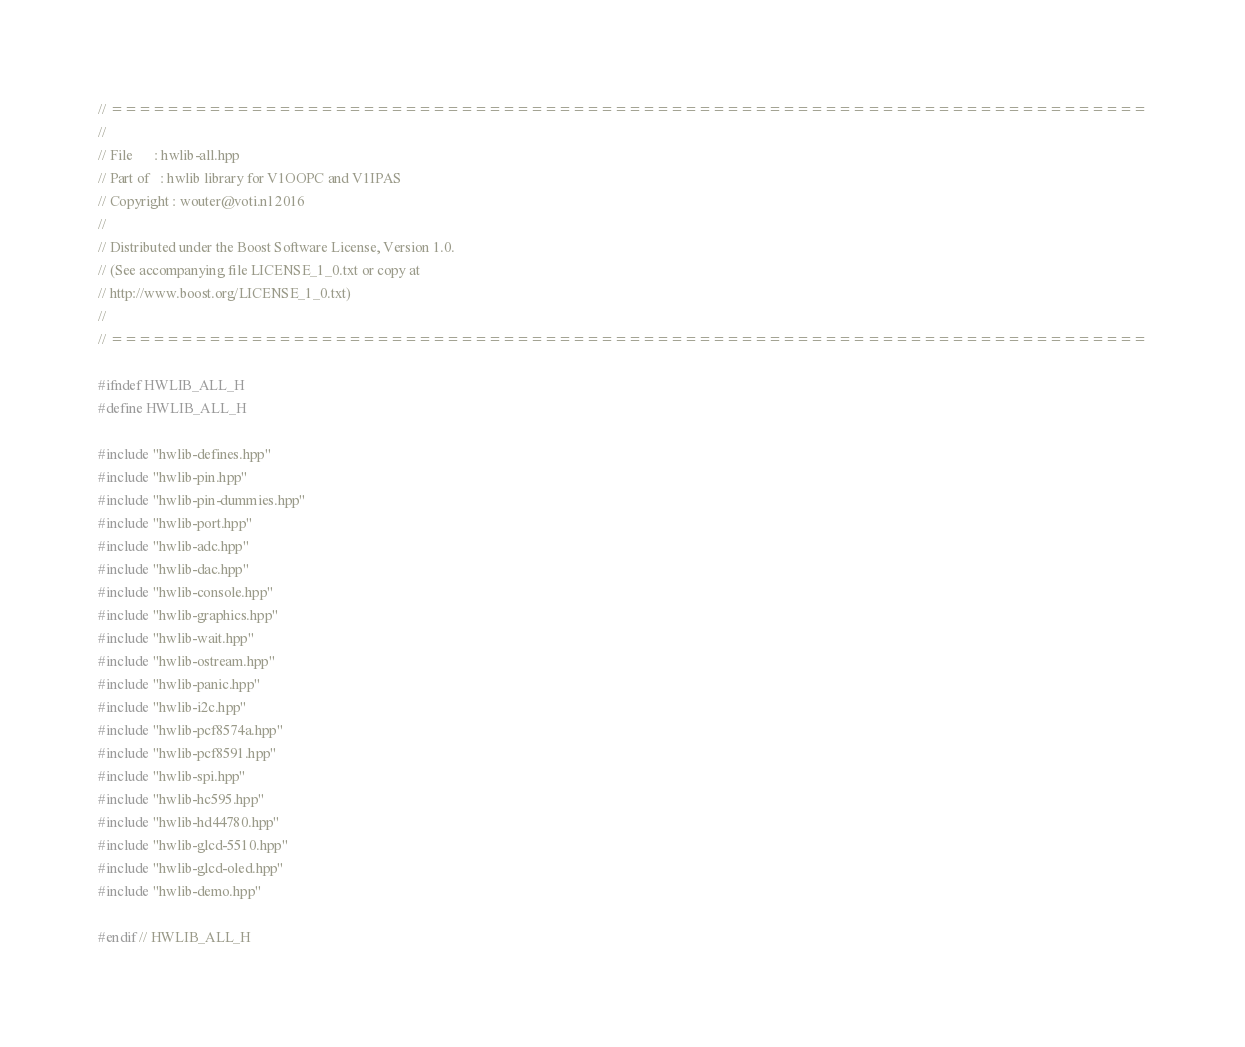Convert code to text. <code><loc_0><loc_0><loc_500><loc_500><_C++_>// ==========================================================================
//
// File      : hwlib-all.hpp
// Part of   : hwlib library for V1OOPC and V1IPAS
// Copyright : wouter@voti.nl 2016
//
// Distributed under the Boost Software License, Version 1.0.
// (See accompanying file LICENSE_1_0.txt or copy at 
// http://www.boost.org/LICENSE_1_0.txt)
//
// ==========================================================================

#ifndef HWLIB_ALL_H
#define HWLIB_ALL_H

#include "hwlib-defines.hpp"
#include "hwlib-pin.hpp"
#include "hwlib-pin-dummies.hpp"
#include "hwlib-port.hpp"
#include "hwlib-adc.hpp"
#include "hwlib-dac.hpp"
#include "hwlib-console.hpp"
#include "hwlib-graphics.hpp"
#include "hwlib-wait.hpp"
#include "hwlib-ostream.hpp"
#include "hwlib-panic.hpp"
#include "hwlib-i2c.hpp"
#include "hwlib-pcf8574a.hpp"
#include "hwlib-pcf8591.hpp"
#include "hwlib-spi.hpp"
#include "hwlib-hc595.hpp"
#include "hwlib-hd44780.hpp"
#include "hwlib-glcd-5510.hpp"
#include "hwlib-glcd-oled.hpp"
#include "hwlib-demo.hpp"

#endif // HWLIB_ALL_H</code> 